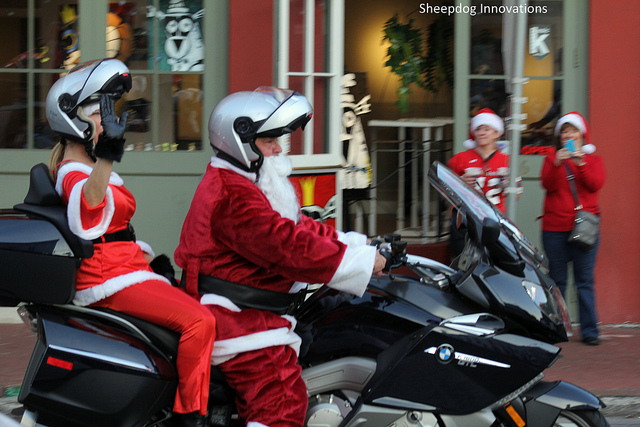Please extract the text content from this image. Sheepdog Innovations 